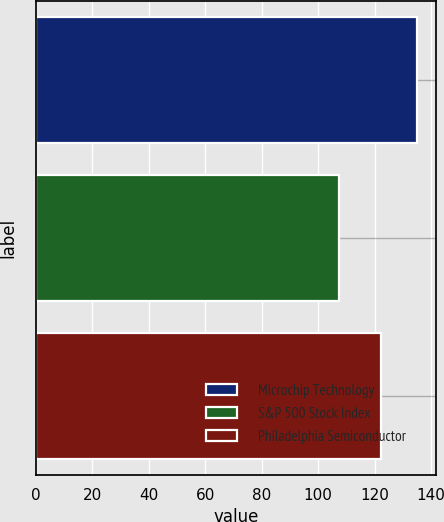<chart> <loc_0><loc_0><loc_500><loc_500><bar_chart><fcel>Microchip Technology<fcel>S&P 500 Stock Index<fcel>Philadelphia Semiconductor<nl><fcel>135.12<fcel>107.23<fcel>122.1<nl></chart> 